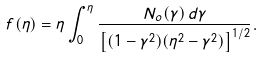Convert formula to latex. <formula><loc_0><loc_0><loc_500><loc_500>f ( \eta ) = \eta \int _ { 0 } ^ { \eta } \frac { N _ { o } ( \gamma ) \, d \gamma } { \left [ ( 1 - \gamma ^ { 2 } ) ( \eta ^ { 2 } - \gamma ^ { 2 } ) \right ] ^ { 1 / 2 } } .</formula> 